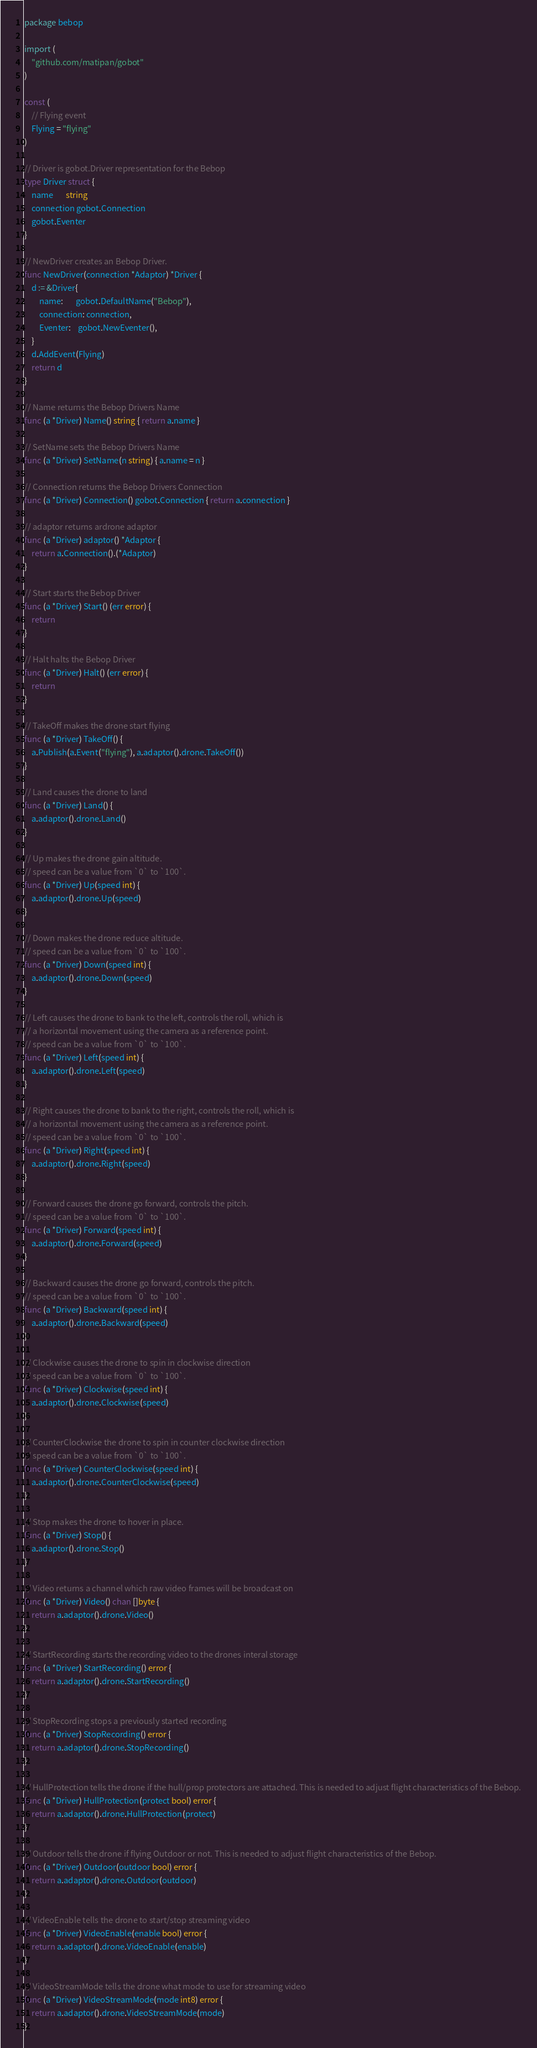<code> <loc_0><loc_0><loc_500><loc_500><_Go_>package bebop

import (
	"github.com/matipan/gobot"
)

const (
	// Flying event
	Flying = "flying"
)

// Driver is gobot.Driver representation for the Bebop
type Driver struct {
	name       string
	connection gobot.Connection
	gobot.Eventer
}

// NewDriver creates an Bebop Driver.
func NewDriver(connection *Adaptor) *Driver {
	d := &Driver{
		name:       gobot.DefaultName("Bebop"),
		connection: connection,
		Eventer:    gobot.NewEventer(),
	}
	d.AddEvent(Flying)
	return d
}

// Name returns the Bebop Drivers Name
func (a *Driver) Name() string { return a.name }

// SetName sets the Bebop Drivers Name
func (a *Driver) SetName(n string) { a.name = n }

// Connection returns the Bebop Drivers Connection
func (a *Driver) Connection() gobot.Connection { return a.connection }

// adaptor returns ardrone adaptor
func (a *Driver) adaptor() *Adaptor {
	return a.Connection().(*Adaptor)
}

// Start starts the Bebop Driver
func (a *Driver) Start() (err error) {
	return
}

// Halt halts the Bebop Driver
func (a *Driver) Halt() (err error) {
	return
}

// TakeOff makes the drone start flying
func (a *Driver) TakeOff() {
	a.Publish(a.Event("flying"), a.adaptor().drone.TakeOff())
}

// Land causes the drone to land
func (a *Driver) Land() {
	a.adaptor().drone.Land()
}

// Up makes the drone gain altitude.
// speed can be a value from `0` to `100`.
func (a *Driver) Up(speed int) {
	a.adaptor().drone.Up(speed)
}

// Down makes the drone reduce altitude.
// speed can be a value from `0` to `100`.
func (a *Driver) Down(speed int) {
	a.adaptor().drone.Down(speed)
}

// Left causes the drone to bank to the left, controls the roll, which is
// a horizontal movement using the camera as a reference point.
// speed can be a value from `0` to `100`.
func (a *Driver) Left(speed int) {
	a.adaptor().drone.Left(speed)
}

// Right causes the drone to bank to the right, controls the roll, which is
// a horizontal movement using the camera as a reference point.
// speed can be a value from `0` to `100`.
func (a *Driver) Right(speed int) {
	a.adaptor().drone.Right(speed)
}

// Forward causes the drone go forward, controls the pitch.
// speed can be a value from `0` to `100`.
func (a *Driver) Forward(speed int) {
	a.adaptor().drone.Forward(speed)
}

// Backward causes the drone go forward, controls the pitch.
// speed can be a value from `0` to `100`.
func (a *Driver) Backward(speed int) {
	a.adaptor().drone.Backward(speed)
}

// Clockwise causes the drone to spin in clockwise direction
// speed can be a value from `0` to `100`.
func (a *Driver) Clockwise(speed int) {
	a.adaptor().drone.Clockwise(speed)
}

// CounterClockwise the drone to spin in counter clockwise direction
// speed can be a value from `0` to `100`.
func (a *Driver) CounterClockwise(speed int) {
	a.adaptor().drone.CounterClockwise(speed)
}

// Stop makes the drone to hover in place.
func (a *Driver) Stop() {
	a.adaptor().drone.Stop()
}

// Video returns a channel which raw video frames will be broadcast on
func (a *Driver) Video() chan []byte {
	return a.adaptor().drone.Video()
}

// StartRecording starts the recording video to the drones interal storage
func (a *Driver) StartRecording() error {
	return a.adaptor().drone.StartRecording()
}

// StopRecording stops a previously started recording
func (a *Driver) StopRecording() error {
	return a.adaptor().drone.StopRecording()
}

// HullProtection tells the drone if the hull/prop protectors are attached. This is needed to adjust flight characteristics of the Bebop.
func (a *Driver) HullProtection(protect bool) error {
	return a.adaptor().drone.HullProtection(protect)
}

// Outdoor tells the drone if flying Outdoor or not. This is needed to adjust flight characteristics of the Bebop.
func (a *Driver) Outdoor(outdoor bool) error {
	return a.adaptor().drone.Outdoor(outdoor)
}

// VideoEnable tells the drone to start/stop streaming video
func (a *Driver) VideoEnable(enable bool) error {
	return a.adaptor().drone.VideoEnable(enable)
}

// VideoStreamMode tells the drone what mode to use for streaming video
func (a *Driver) VideoStreamMode(mode int8) error {
	return a.adaptor().drone.VideoStreamMode(mode)
}
</code> 